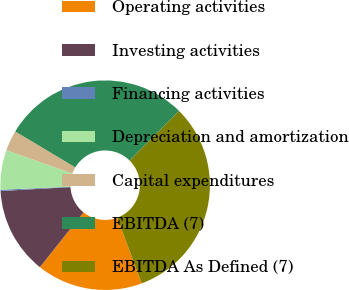<chart> <loc_0><loc_0><loc_500><loc_500><pie_chart><fcel>Operating activities<fcel>Investing activities<fcel>Financing activities<fcel>Depreciation and amortization<fcel>Capital expenditures<fcel>EBITDA (7)<fcel>EBITDA As Defined (7)<nl><fcel>16.37%<fcel>13.41%<fcel>0.19%<fcel>6.12%<fcel>3.15%<fcel>28.9%<fcel>31.86%<nl></chart> 